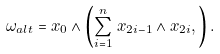<formula> <loc_0><loc_0><loc_500><loc_500>\omega _ { a l t } = x _ { 0 } \wedge \left ( \sum _ { i = 1 } ^ { n } \, x _ { 2 i - 1 } \wedge x _ { 2 i } , \right ) .</formula> 